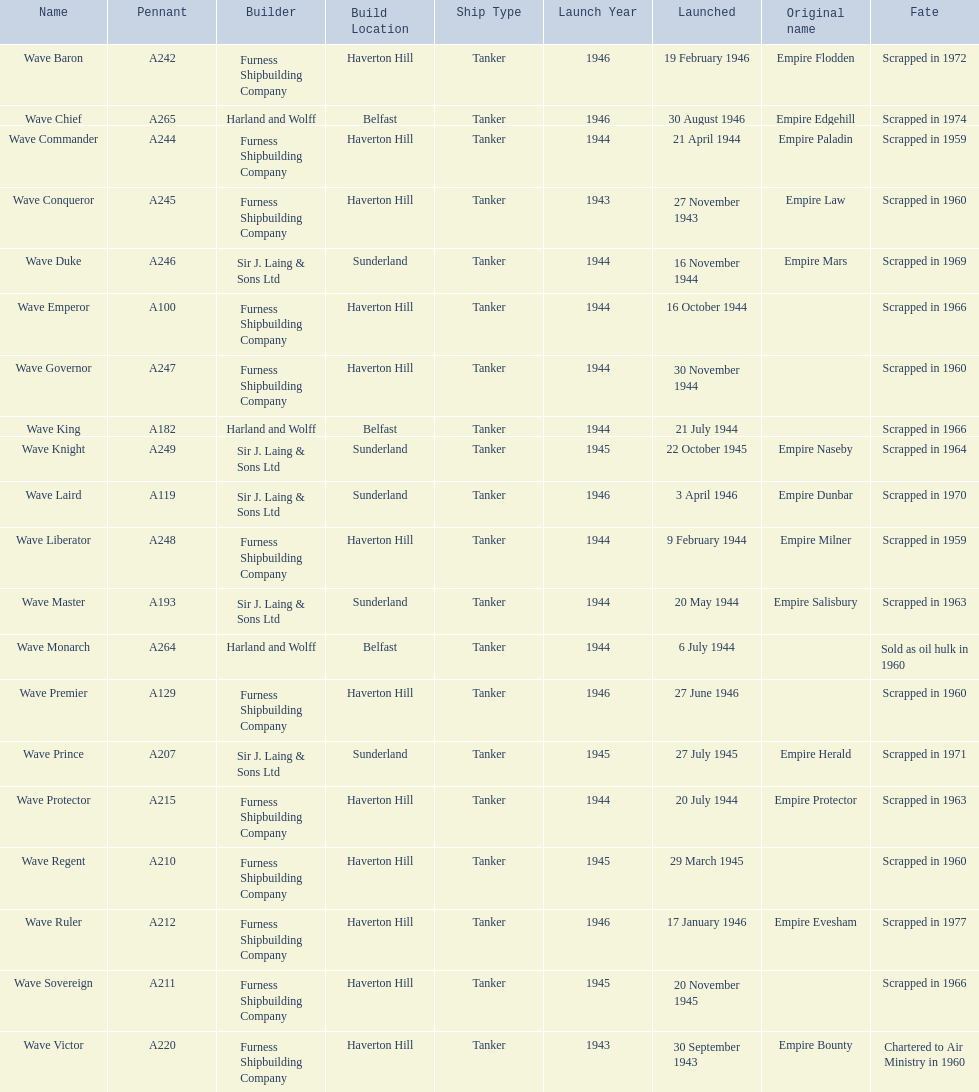What was the succeeding wave class oiler post wave emperor? Wave Duke. 